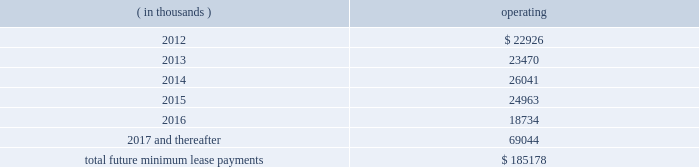The company monitors the financial health and stability of its lenders under the revolving credit and long term debt facilities , however during any period of significant instability in the credit markets lenders could be negatively impacted in their ability to perform under these facilities .
In july 2011 , in connection with the company 2019s acquisition of its corporate headquarters , the company assumed a $ 38.6 million nonrecourse loan secured by a mortgage on the acquired property .
The acquisition of the company 2019s corporate headquarters was accounted for as a business combination , and the carrying value of the loan secured by the acquired property approximates fair value .
The assumed loan had an original term of approximately ten years with a scheduled maturity date of march 1 , 2013 .
The loan includes a balloon payment of $ 37.3 million due at maturity , and may not be prepaid .
The assumed loan is nonrecourse with the lender 2019s remedies for non-performance limited to action against the acquired property and certain required reserves and a cash collateral account , except for nonrecourse carve outs related to fraud , breaches of certain representations , warranties or covenants , including those related to environmental matters , and other standard carve outs for a loan of this type .
The loan requires certain minimum cash flows and financial results from the property , and if those requirements are not met , additional reserves may be required .
The assumed loan requires prior approval of the lender for certain matters related to the property , including material leases , changes to property management , transfers of any part of the property and material alterations to the property .
The loan has an interest rate of 6.73% ( 6.73 % ) .
In connection with the assumed loan , the company incurred and capitalized $ 0.8 million in deferred financing costs .
As of december 31 , 2011 , the outstanding balance on the loan was $ 38.2 million .
In addition , in connection with the assumed loan for the acquisition of its corporate headquarters , the company was required to set aside amounts in reserve and cash collateral accounts .
As of december 31 , 2011 , $ 2.0 million of restricted cash was included in prepaid expenses and other current assets , and the remaining $ 3.0 million of restricted cash was included in other long term assets .
Interest expense was $ 3.9 million , $ 2.3 million and $ 2.4 million for the years ended december 31 , 2011 , 2010 and 2009 , respectively .
Interest expense includes the amortization of deferred financing costs and interest expense under the credit and long term debt facilities , as well as the assumed loan discussed above .
Commitments and contingencies obligations under operating leases the company leases warehouse space , office facilities , space for its retail stores and certain equipment under non-cancelable operating leases .
The leases expire at various dates through 2023 , excluding extensions at the company 2019s option , and include provisions for rental adjustments .
The table below includes executed lease agreements for factory house stores that the company did not yet occupy as of december 31 , 2011 and does not include contingent rent the company may incur at its retail stores based on future sales above a specified limit .
The following is a schedule of future minimum lease payments for non-cancelable real property operating leases as of december 31 , 2011 : ( in thousands ) operating .
Included in selling , general and administrative expense was rent expense of $ 26.7 million , $ 21.3 million and $ 14.1 million for the years ended december 31 , 2011 , 2010 and 2009 , respectively , under non-cancelable .
What was the percentage increase in the rent expense from 2010 to 2011? 
Rationale: the rent expense increased by 25.4% from 2010 to 2011
Computations: ((26.7 - 21.3) / 21.3)
Answer: 0.25352. The company monitors the financial health and stability of its lenders under the revolving credit and long term debt facilities , however during any period of significant instability in the credit markets lenders could be negatively impacted in their ability to perform under these facilities .
In july 2011 , in connection with the company 2019s acquisition of its corporate headquarters , the company assumed a $ 38.6 million nonrecourse loan secured by a mortgage on the acquired property .
The acquisition of the company 2019s corporate headquarters was accounted for as a business combination , and the carrying value of the loan secured by the acquired property approximates fair value .
The assumed loan had an original term of approximately ten years with a scheduled maturity date of march 1 , 2013 .
The loan includes a balloon payment of $ 37.3 million due at maturity , and may not be prepaid .
The assumed loan is nonrecourse with the lender 2019s remedies for non-performance limited to action against the acquired property and certain required reserves and a cash collateral account , except for nonrecourse carve outs related to fraud , breaches of certain representations , warranties or covenants , including those related to environmental matters , and other standard carve outs for a loan of this type .
The loan requires certain minimum cash flows and financial results from the property , and if those requirements are not met , additional reserves may be required .
The assumed loan requires prior approval of the lender for certain matters related to the property , including material leases , changes to property management , transfers of any part of the property and material alterations to the property .
The loan has an interest rate of 6.73% ( 6.73 % ) .
In connection with the assumed loan , the company incurred and capitalized $ 0.8 million in deferred financing costs .
As of december 31 , 2011 , the outstanding balance on the loan was $ 38.2 million .
In addition , in connection with the assumed loan for the acquisition of its corporate headquarters , the company was required to set aside amounts in reserve and cash collateral accounts .
As of december 31 , 2011 , $ 2.0 million of restricted cash was included in prepaid expenses and other current assets , and the remaining $ 3.0 million of restricted cash was included in other long term assets .
Interest expense was $ 3.9 million , $ 2.3 million and $ 2.4 million for the years ended december 31 , 2011 , 2010 and 2009 , respectively .
Interest expense includes the amortization of deferred financing costs and interest expense under the credit and long term debt facilities , as well as the assumed loan discussed above .
Commitments and contingencies obligations under operating leases the company leases warehouse space , office facilities , space for its retail stores and certain equipment under non-cancelable operating leases .
The leases expire at various dates through 2023 , excluding extensions at the company 2019s option , and include provisions for rental adjustments .
The table below includes executed lease agreements for factory house stores that the company did not yet occupy as of december 31 , 2011 and does not include contingent rent the company may incur at its retail stores based on future sales above a specified limit .
The following is a schedule of future minimum lease payments for non-cancelable real property operating leases as of december 31 , 2011 : ( in thousands ) operating .
Included in selling , general and administrative expense was rent expense of $ 26.7 million , $ 21.3 million and $ 14.1 million for the years ended december 31 , 2011 , 2010 and 2009 , respectively , under non-cancelable .
As of december 312012 what was the percent of the schedule of future minimum lease payments for non-cancelable real property operating as part of the total? 
Computations: (22926 / 185178)
Answer: 0.12381. 